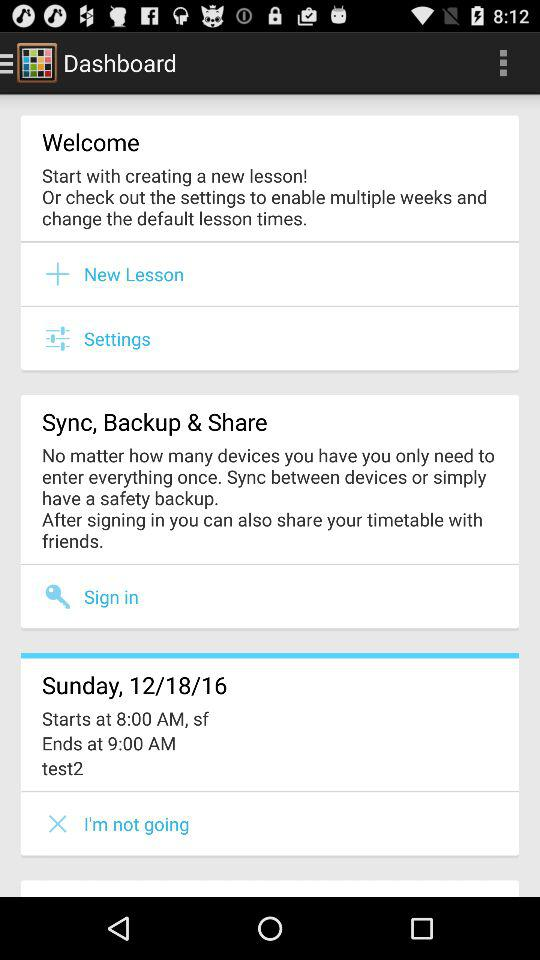What is the date of "test2"? The date is Sunday, December 18, 2016. 